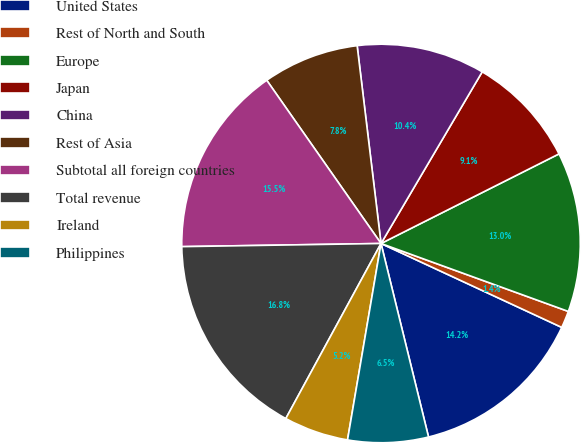<chart> <loc_0><loc_0><loc_500><loc_500><pie_chart><fcel>United States<fcel>Rest of North and South<fcel>Europe<fcel>Japan<fcel>China<fcel>Rest of Asia<fcel>Subtotal all foreign countries<fcel>Total revenue<fcel>Ireland<fcel>Philippines<nl><fcel>14.25%<fcel>1.38%<fcel>12.96%<fcel>9.1%<fcel>10.39%<fcel>7.81%<fcel>15.53%<fcel>16.82%<fcel>5.24%<fcel>6.52%<nl></chart> 